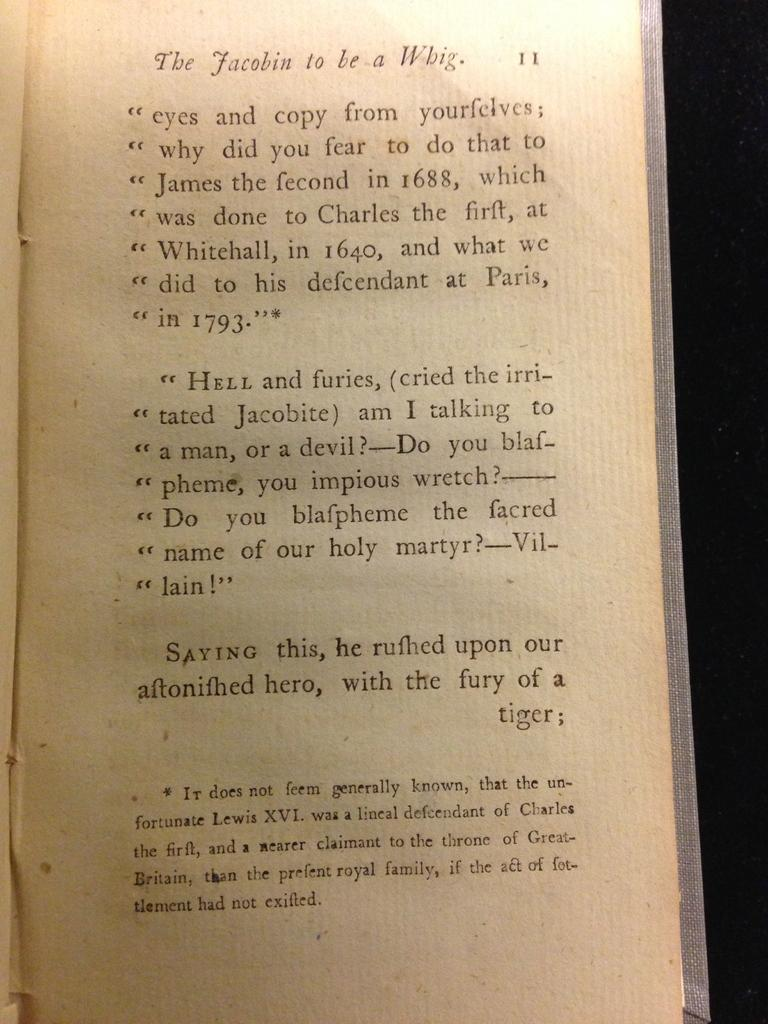<image>
Provide a brief description of the given image. A page 11 from The Jacobin to be a Whig. 